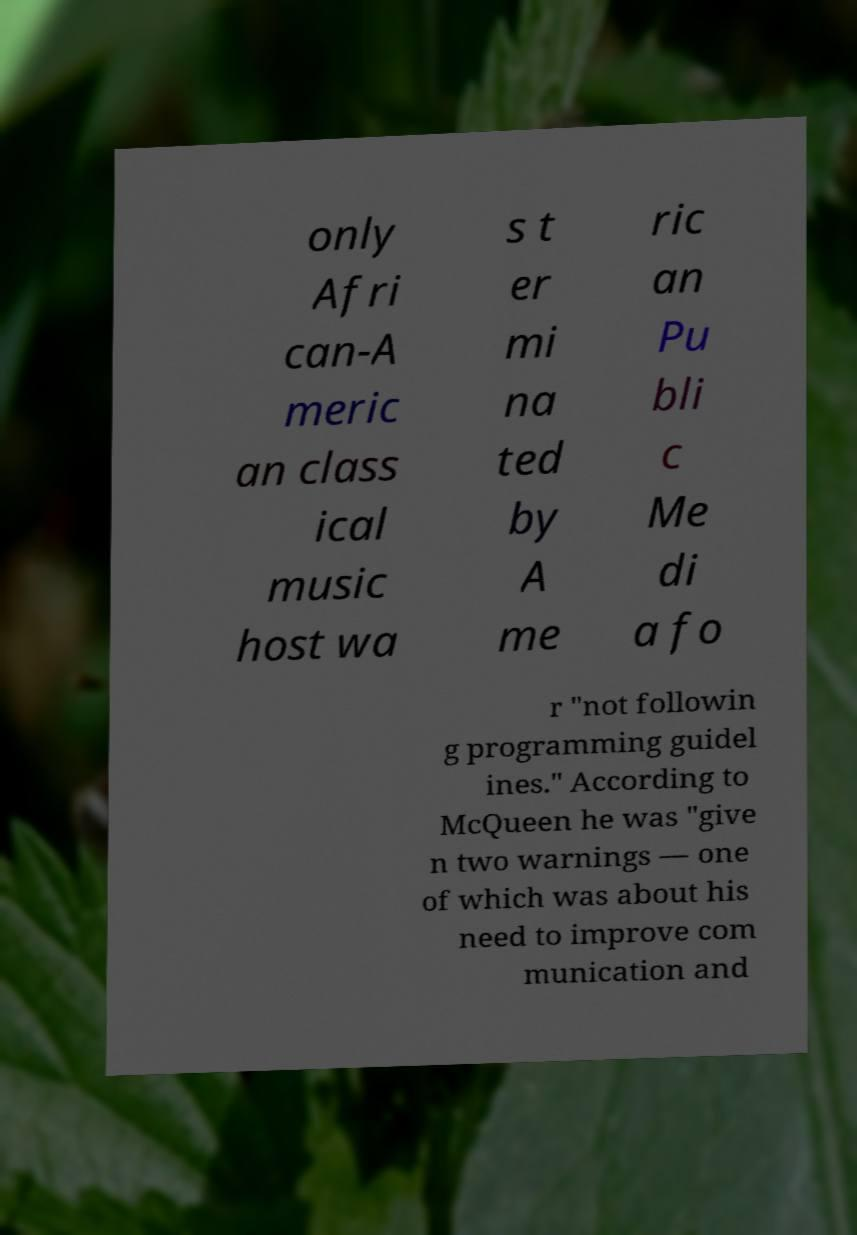Please identify and transcribe the text found in this image. only Afri can-A meric an class ical music host wa s t er mi na ted by A me ric an Pu bli c Me di a fo r "not followin g programming guidel ines." According to McQueen he was "give n two warnings — one of which was about his need to improve com munication and 